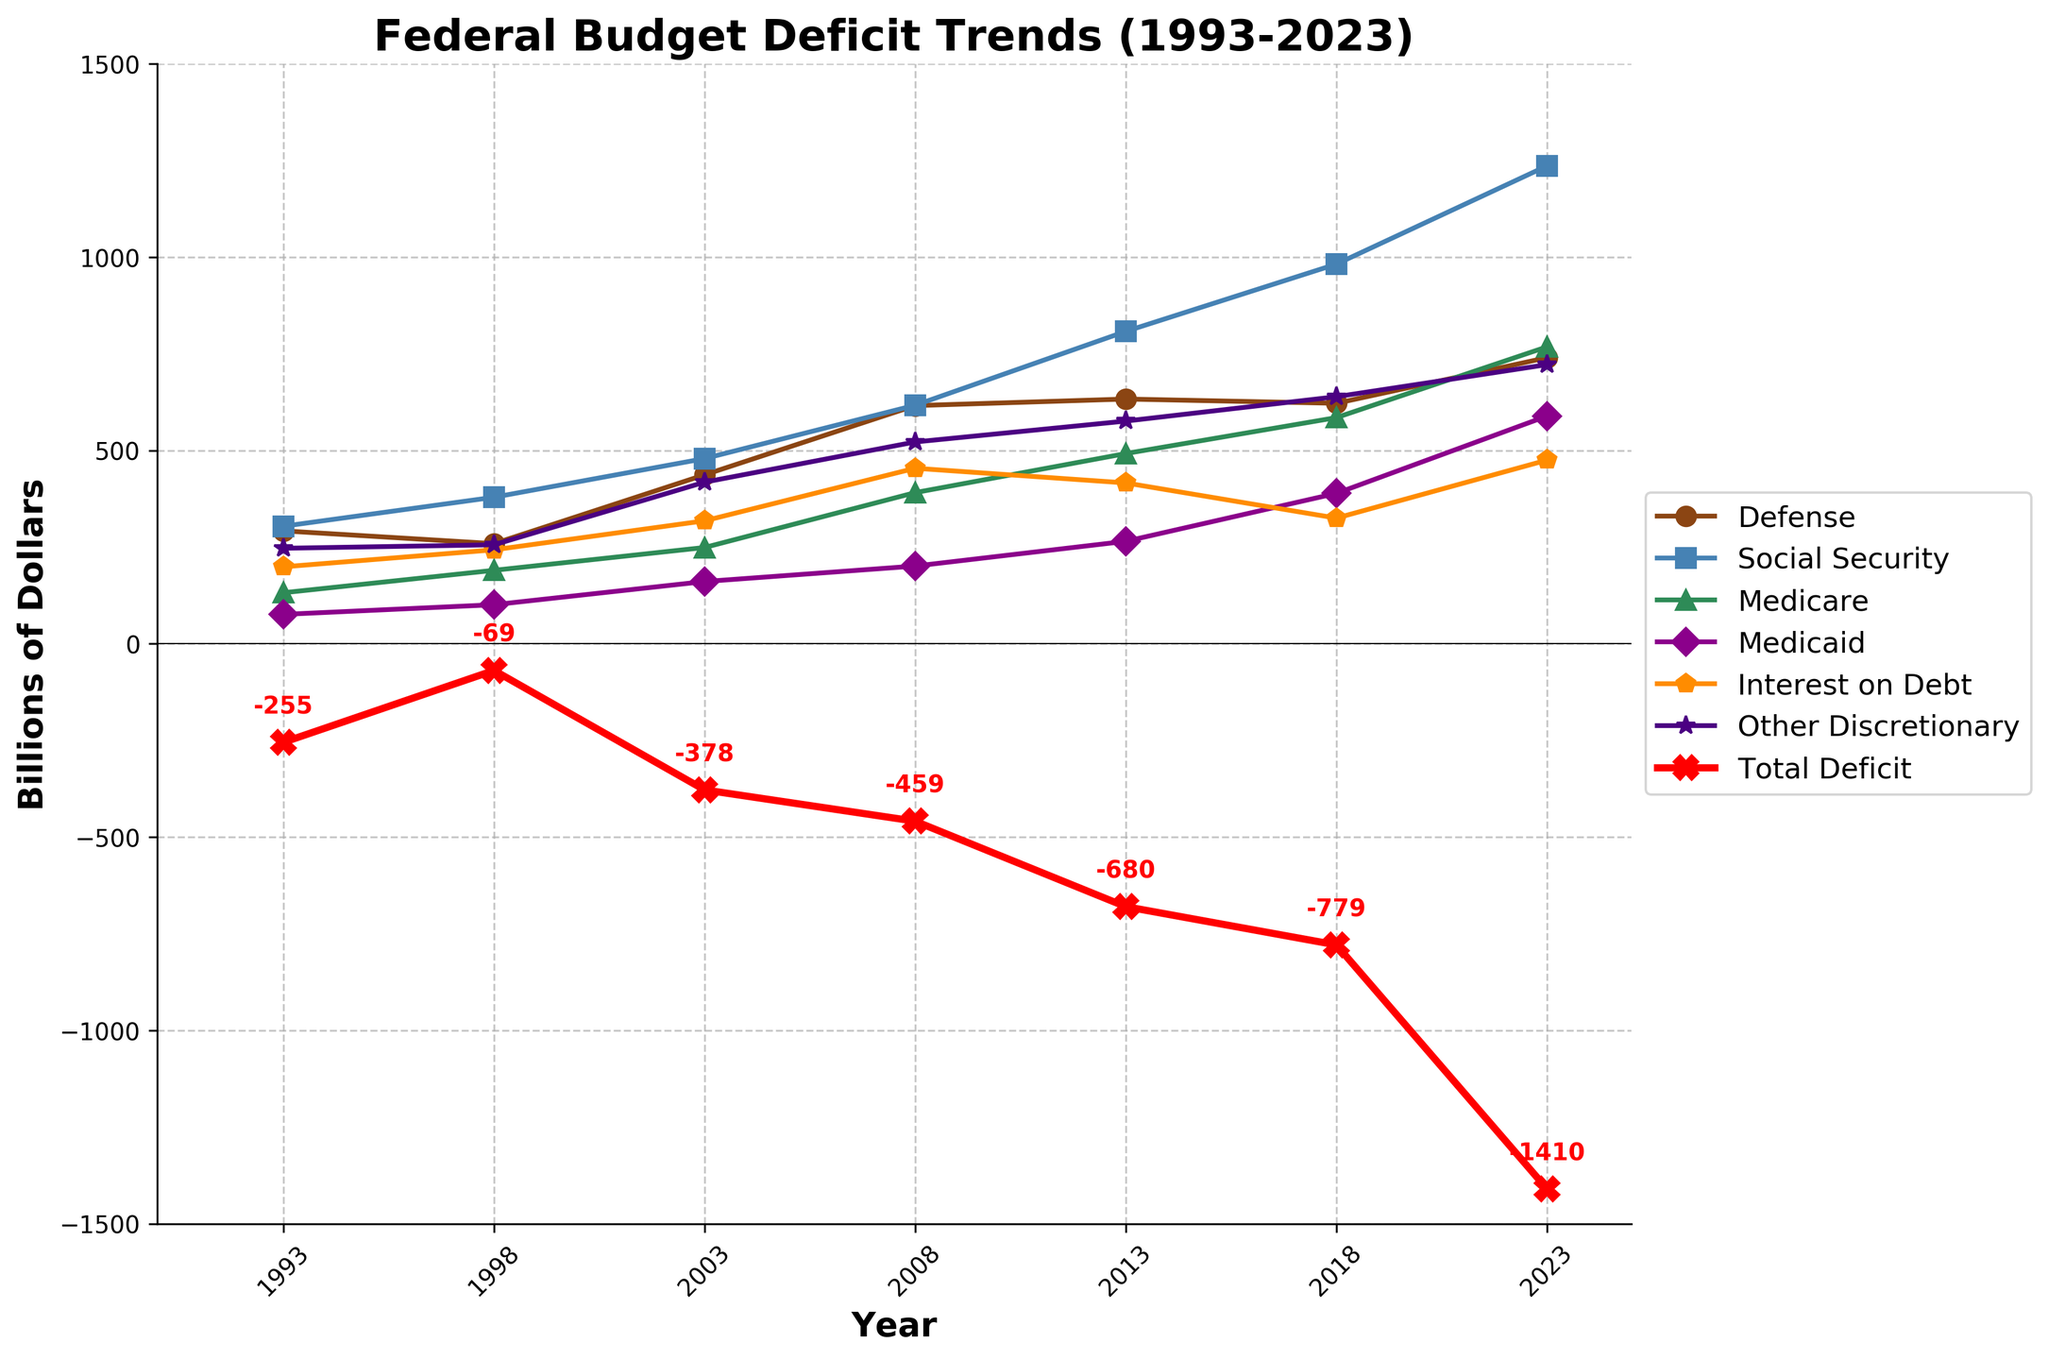What's the trend in Total Deficit over the years? The Total Deficit is plotted with a red X marker and a thicker line. From the figure, it starts at -255 billion dollars in 1993, decreases to -69 billion in 1998, then increases and fluctuates, reaching -1410 billion in 2023. The trend shows an overall increase in the Total Deficit over the years.
Answer: It increases Which spending category had the highest value in 2023? The highest value in 2023 among the categorized spending areas can be observed visually. Social Security spending, represented by a blue line and square markers, has the highest value.
Answer: Social Security How did Defense spending change from 1993 to 2023? By tracing the brown line with circle markers, we see that Defense spending increased from 292 billion dollars in 1993 to 740 billion dollars in 2023.
Answer: Increased What is the difference between Social Security spending in 1998 and 2023? In 1998, Social Security spending was 379 billion dollars. In 2023, it was 1236 billion dollars. The difference is 1236 - 379 = 857 billion dollars.
Answer: 857 billion dollars Which year shows the smallest Total Deficit? By comparing the red X markers, 1998 shows the smallest Total Deficit at -69 billion dollars.
Answer: 1998 Compare the interest on debt in 2003 and 2018. The orange line with the corresponding marker indicates 318 billion dollars in 2003 and 325 billion dollars in 2018. The values are almost similar with a slight increase in 2018.
Answer: Similar with a slight increase What is the cumulative Total Deficit from 1993 to 2023? Summing the Total Deficits from 1993 (-255), 1998 (-69), 2003 (-378), 2008 (-459), 2013 (-680), 2018 (-779), and 2023 (-1410) results in -4030 billion dollars.
Answer: -4030 billion dollars Which year had the largest increase in Medicaid spending compared to the previous period? Observing the purple line with diamond markers, the largest increase appears between 2018 (389 billion) and 2023 (589 billion), which is an increase of 200 billion.
Answer: Between 2018 and 2023 How did Medicare spending trend from 2003 to 2018? The green line with triangular markers for Medicare shows an upward trend, rising from 249 billion in 2003 to 585 billion in 2018.
Answer: Upward trend What spending category had the least increase from 1993 to 2023? Among observed categories, Defense spending (brown line) increased from 292 billion to 740 billion dollars, which appears to be the smallest increase compared to others.
Answer: Defense 